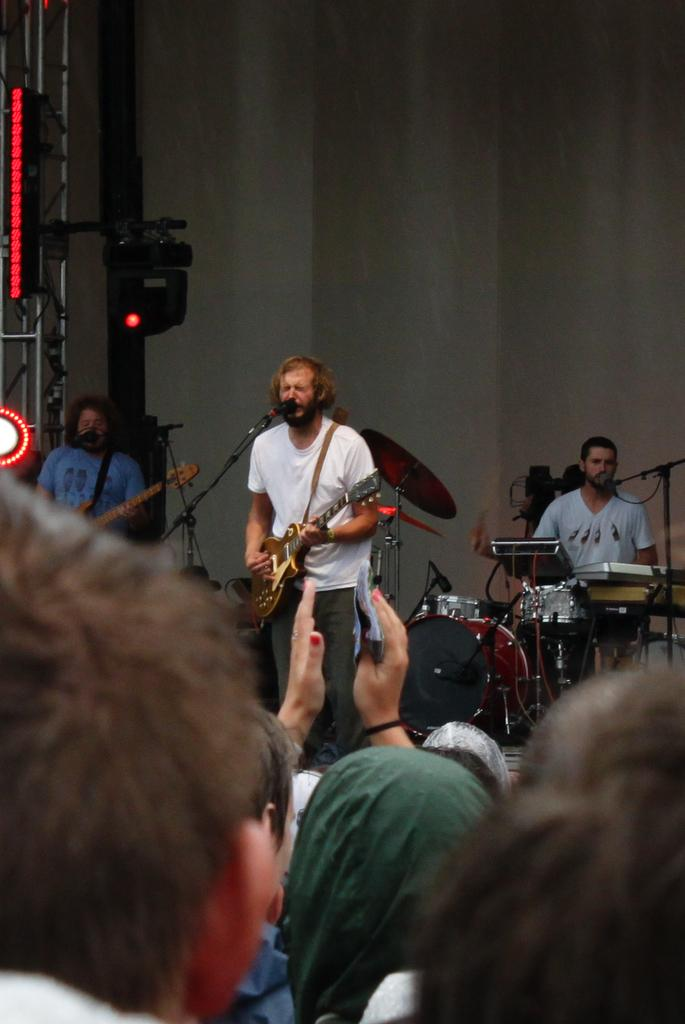How many people are on the stage in the image? There are three people on the stage in the image. What are the people on the stage doing? The people on the stage are holding musical instruments and playing them. Can you describe the people on the floor in the image? The facts provided do not mention any details about the people on the floor, so we cannot describe them. What type of thread is being used by the children in the image? There are no children or thread present in the image. Where is the trip taking place in the image? There is no trip or location mentioned in the image. 